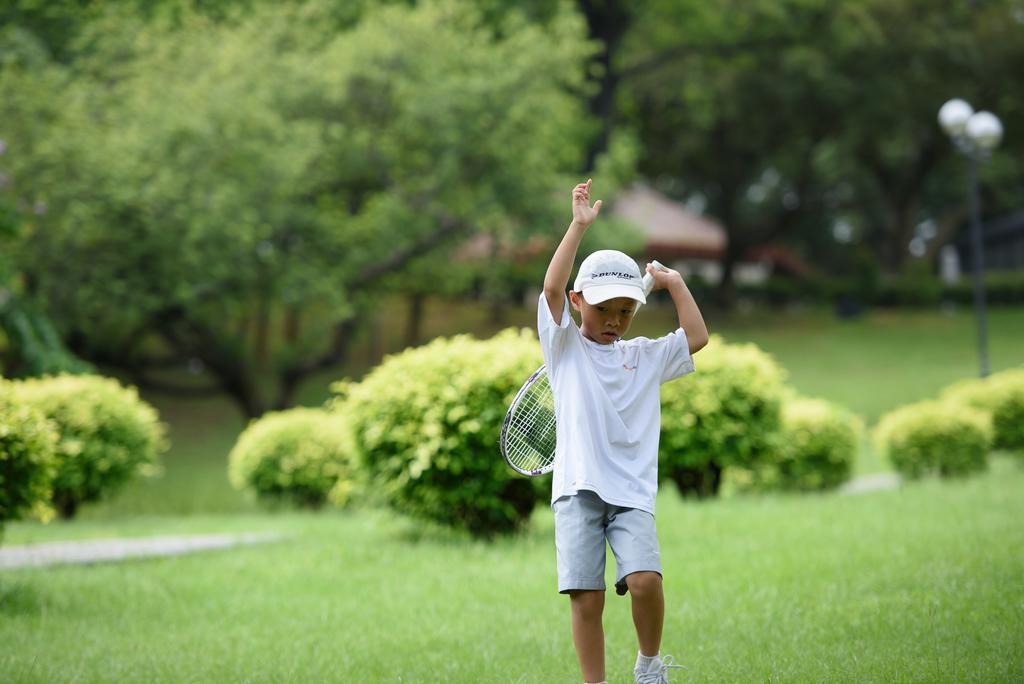In one or two sentences, can you explain what this image depicts? In this image, we can see a kid wearing a T-shirt and shorts is holding a shuttle racket. We can see the ground. We can see some grass, plants and a few trees. We can also see some houses and a pole with lights. 